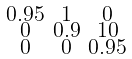Convert formula to latex. <formula><loc_0><loc_0><loc_500><loc_500>\begin{smallmatrix} 0 . 9 5 & 1 & 0 \\ 0 & 0 . 9 & 1 0 \\ 0 & 0 & 0 . 9 5 \end{smallmatrix}</formula> 